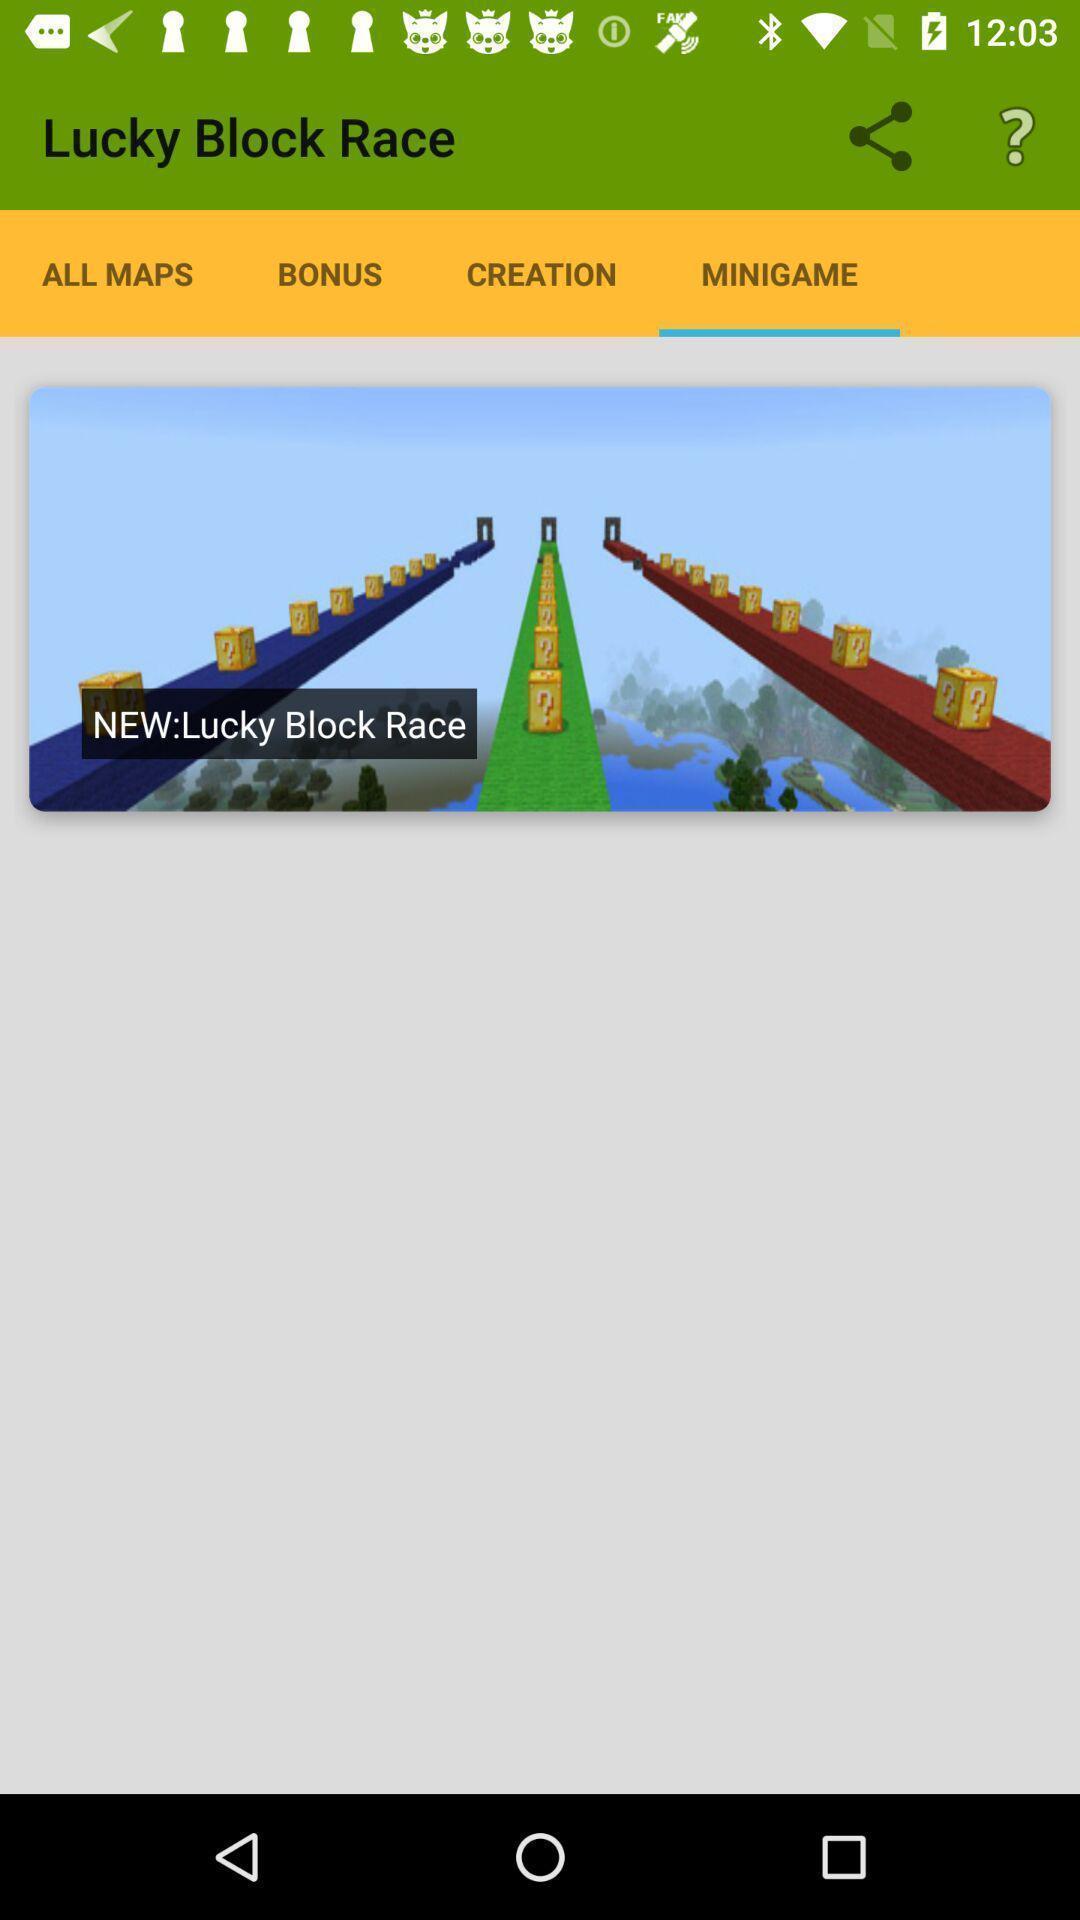Give me a narrative description of this picture. Screen displaying the game page. 